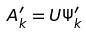<formula> <loc_0><loc_0><loc_500><loc_500>A ^ { \prime } _ { k } = U \Psi ^ { \prime } _ { k }</formula> 